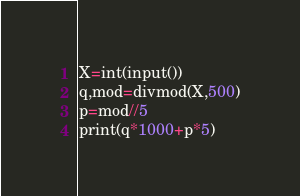<code> <loc_0><loc_0><loc_500><loc_500><_Python_>X=int(input())
q,mod=divmod(X,500)
p=mod//5
print(q*1000+p*5)</code> 